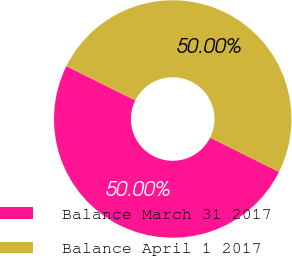Convert chart to OTSL. <chart><loc_0><loc_0><loc_500><loc_500><pie_chart><fcel>Balance March 31 2017<fcel>Balance April 1 2017<nl><fcel>50.0%<fcel>50.0%<nl></chart> 